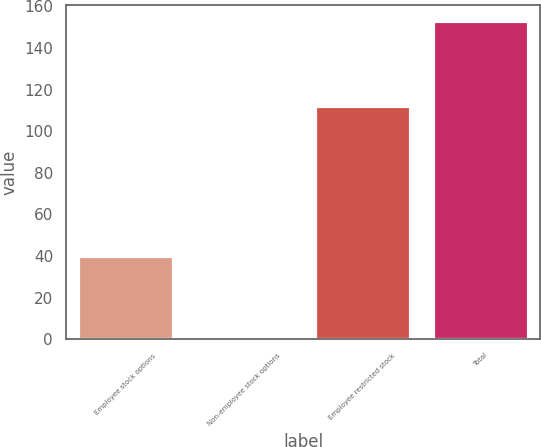<chart> <loc_0><loc_0><loc_500><loc_500><bar_chart><fcel>Employee stock options<fcel>Non-employee stock options<fcel>Employee restricted stock<fcel>Total<nl><fcel>40<fcel>1<fcel>112<fcel>153<nl></chart> 